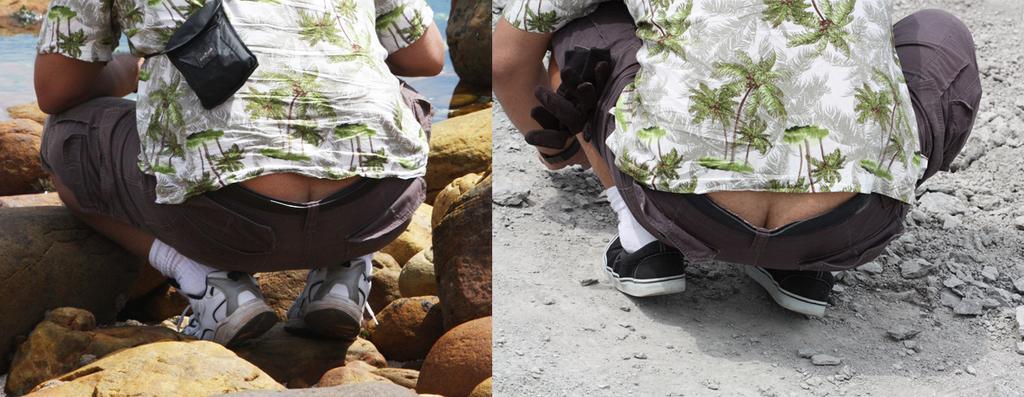How would you summarize this image in a sentence or two? This is a collage picture and in this picture we can see two people, stones, bag and some objects. 